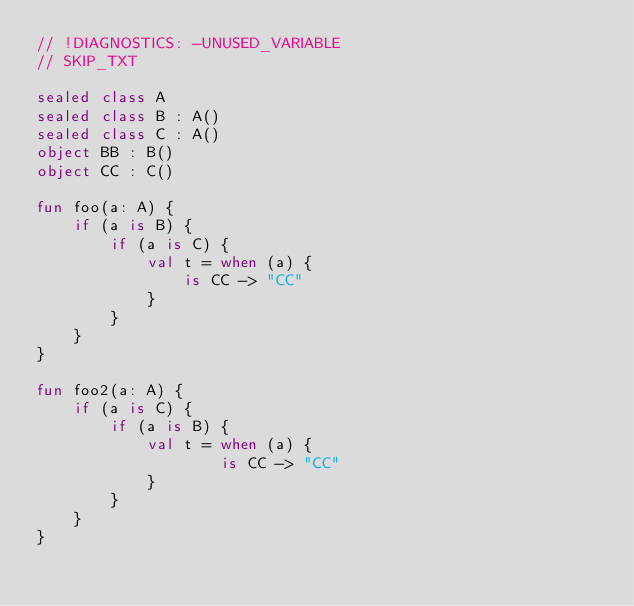<code> <loc_0><loc_0><loc_500><loc_500><_Kotlin_>// !DIAGNOSTICS: -UNUSED_VARIABLE
// SKIP_TXT

sealed class A
sealed class B : A()
sealed class C : A()
object BB : B()
object CC : C()

fun foo(a: A) {
    if (a is B) {
        if (a is C) {
            val t = when (a) {
                is CC -> "CC"
            }
        }
    }
}

fun foo2(a: A) {
    if (a is C) {
        if (a is B) {
            val t = when (a) {
                    is CC -> "CC"
            }
        }
    }
}</code> 